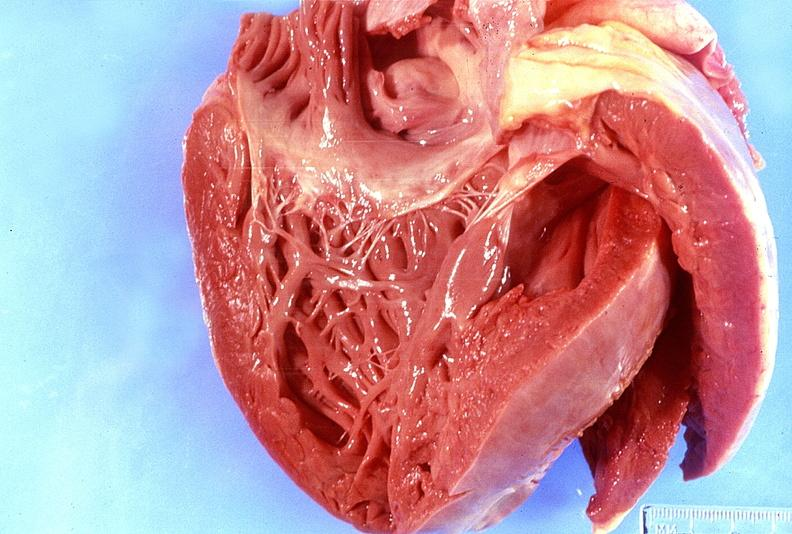where is this?
Answer the question using a single word or phrase. Heart 